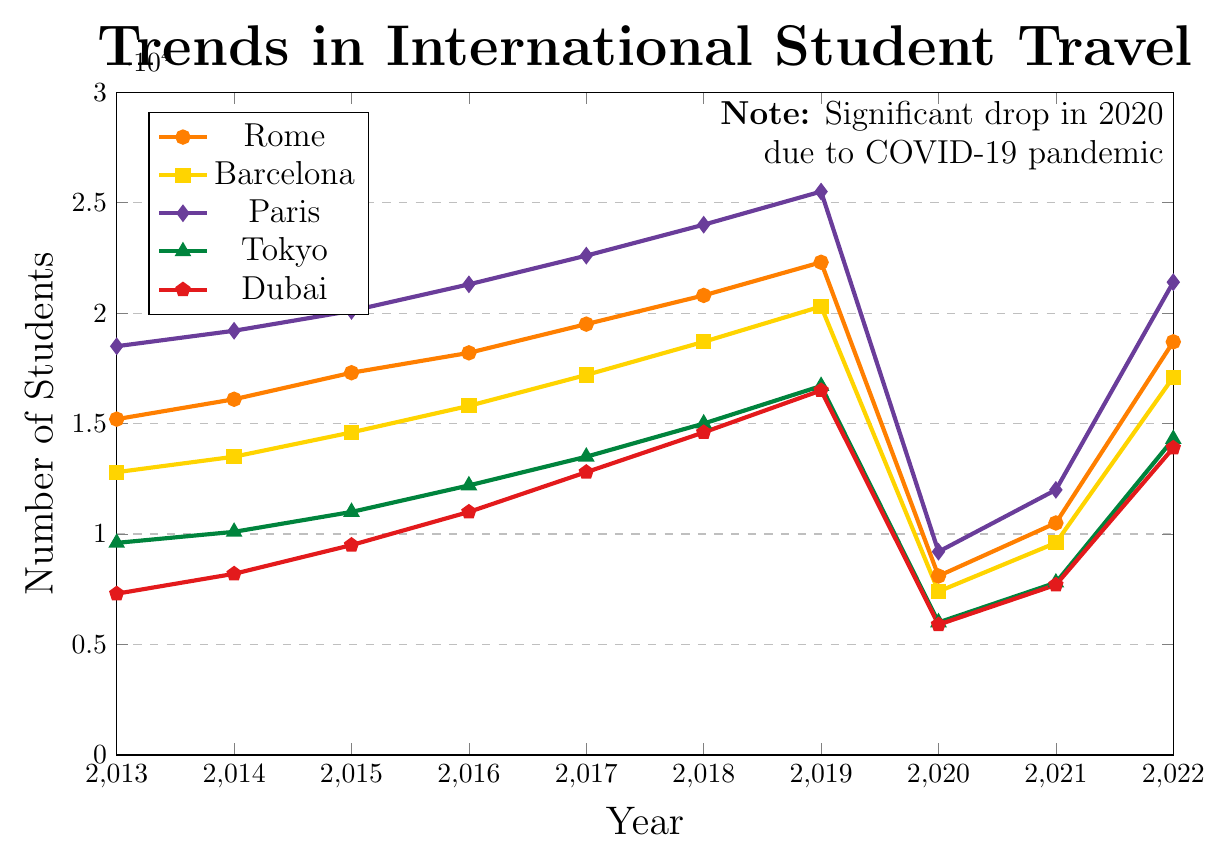What was the percentage increase in the number of students traveling to Rome from 2013 to 2019? To calculate the percentage increase: First, find the difference in the number of students between 2019 and 2013, which is 22300 - 15200 = 7100. Then, divide this difference by the 2013 value: 7100 / 15200 = 0.4671. Finally, multiply by 100 to get the percentage: 0.4671 * 100 ≈ 46.71%
Answer: 46.71% Which city had the highest number of student travelers in 2017? Look at the data points for 2017 and compare the values: Rome (19500), Barcelona (17200), Paris (22600), Tokyo (13500), and Dubai (12800). Paris has the highest value with 22600 students.
Answer: Paris In which year did Tokyo see the highest number of student travelers, and what was the number? Identify the highest data point for Tokyo over the years. Tokyo had the highest number of student travelers in 2019 with 16700 students.
Answer: 2019, 16700 Which city experienced the most significant drop in student travelers from 2019 to 2020? Find the difference in the number of students for each city from 2019 to 2020: Rome (22300 - 8100 = 14200), Barcelona (20300 - 7400 = 12900), Paris (25500 - 9200 = 16300), Tokyo (16700 - 6000 = 10700), and Dubai (16500 - 5900 = 10600). Paris experienced the most significant drop with a decrease of 16300 students.
Answer: Paris How did the number of student travelers to Dubai change from 2014 to 2018? Calculate the difference in student travelers to Dubai between 2018 and 2014: 14600 - 8200 = 6400. Therefore, the number of student travelers to Dubai increased by 6400 from 2014 to 2018.
Answer: Increased by 6400 What was the trend in the number of student travelers to all cities in 2020 compared to 2019? Compare the data for all cities in 2019 and 2020. There was a drop for each city due to the significant decrease in 2020 compared to 2019: Rome (22300 to 8100), Barcelona (20300 to 7400), Paris (25500 to 9200), Tokyo (16700 to 6000), and Dubai (16500 to 5900).
Answer: Decrease How does the number of student travelers to Paris in 2021 compare to 2018? Compare the values for Paris in 2021 (12000) and 2018 (24000). The number of student travelers in 2021 is 12000, which is 12000 fewer than in 2018. This means the number was halved.
Answer: 12000 less Which city had the least number of student travelers in 2022, and what's the number? Look at the data for all cities in 2022 and find the minimum value: Rome (18700), Barcelona (17100), Paris (21400), Tokyo (14300), and Dubai (13900). Dubai had the least number of student travelers with 13900.
Answer: Dubai, 13900 Calculate the average number of student travelers to Rome from 2013 to 2019. Sum the number of student travelers to Rome from 2013 to 2019 and divide by the number of years: (15200 + 16100 + 17300 + 18200 + 19500 + 20800 + 22300) / 7 = 129400 / 7 = 18485.71 ≈ 18486
Answer: 18486 